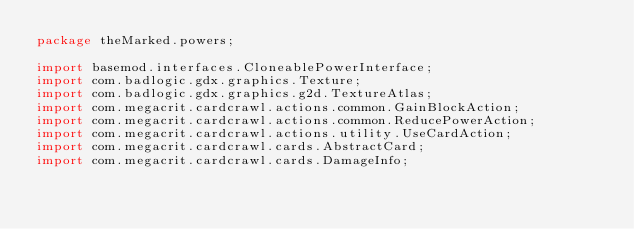Convert code to text. <code><loc_0><loc_0><loc_500><loc_500><_Java_>package theMarked.powers;

import basemod.interfaces.CloneablePowerInterface;
import com.badlogic.gdx.graphics.Texture;
import com.badlogic.gdx.graphics.g2d.TextureAtlas;
import com.megacrit.cardcrawl.actions.common.GainBlockAction;
import com.megacrit.cardcrawl.actions.common.ReducePowerAction;
import com.megacrit.cardcrawl.actions.utility.UseCardAction;
import com.megacrit.cardcrawl.cards.AbstractCard;
import com.megacrit.cardcrawl.cards.DamageInfo;</code> 